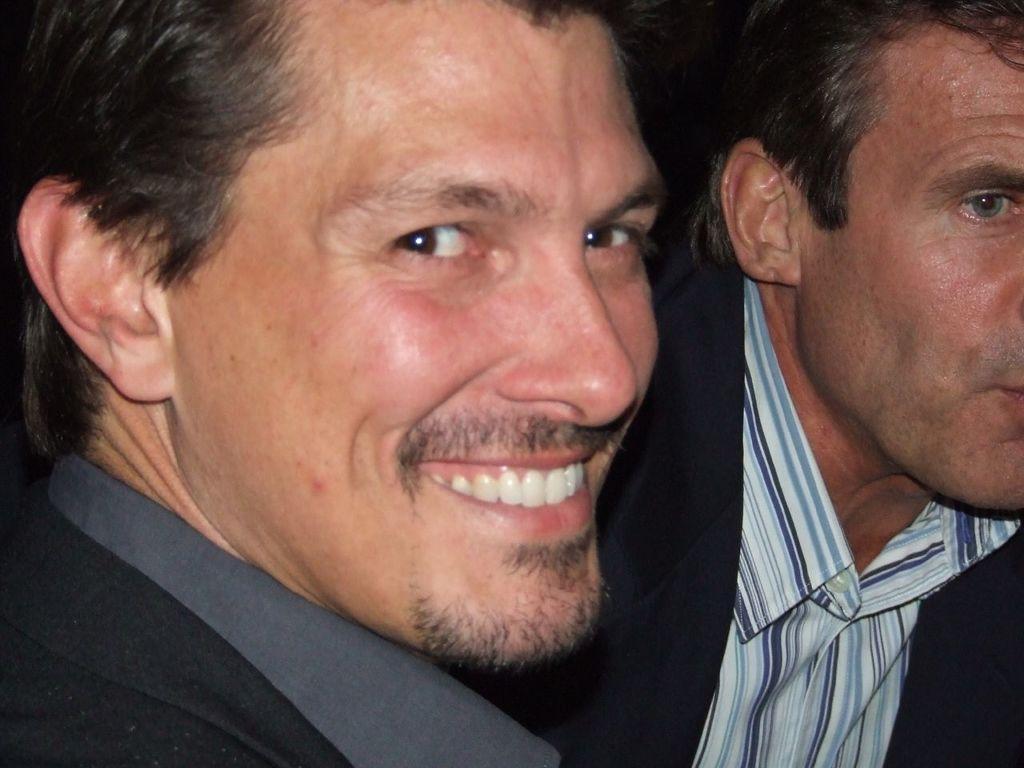How would you summarize this image in a sentence or two? In this image there are two men, they are wearing suits, they are wearing shirts. 